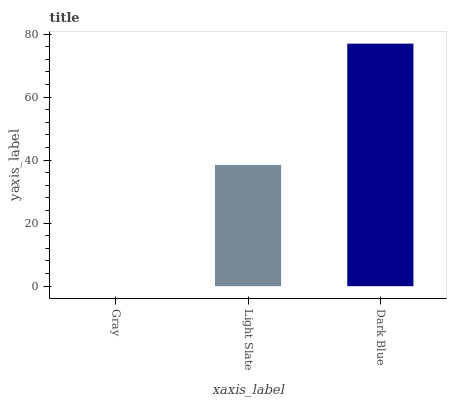Is Gray the minimum?
Answer yes or no. Yes. Is Dark Blue the maximum?
Answer yes or no. Yes. Is Light Slate the minimum?
Answer yes or no. No. Is Light Slate the maximum?
Answer yes or no. No. Is Light Slate greater than Gray?
Answer yes or no. Yes. Is Gray less than Light Slate?
Answer yes or no. Yes. Is Gray greater than Light Slate?
Answer yes or no. No. Is Light Slate less than Gray?
Answer yes or no. No. Is Light Slate the high median?
Answer yes or no. Yes. Is Light Slate the low median?
Answer yes or no. Yes. Is Gray the high median?
Answer yes or no. No. Is Dark Blue the low median?
Answer yes or no. No. 